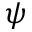Convert formula to latex. <formula><loc_0><loc_0><loc_500><loc_500>\psi</formula> 